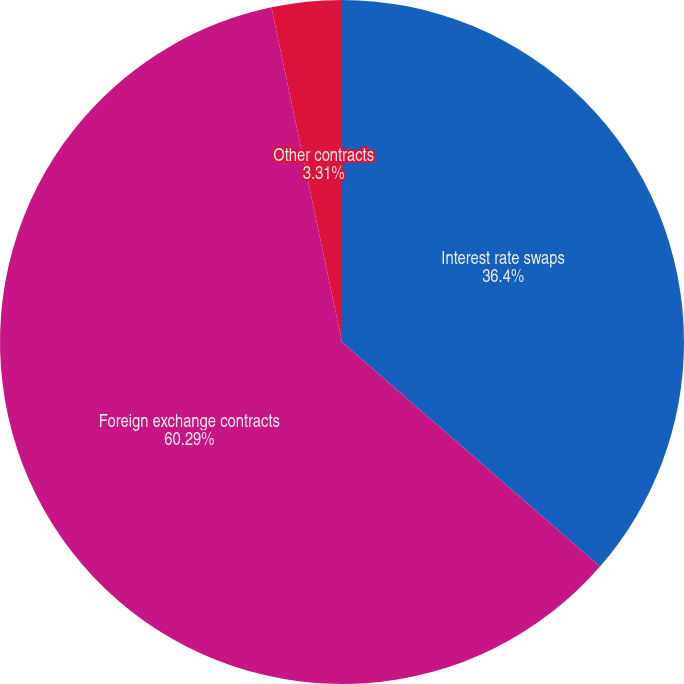<chart> <loc_0><loc_0><loc_500><loc_500><pie_chart><fcel>Interest rate swaps<fcel>Foreign exchange contracts<fcel>Other contracts<nl><fcel>36.4%<fcel>60.29%<fcel>3.31%<nl></chart> 